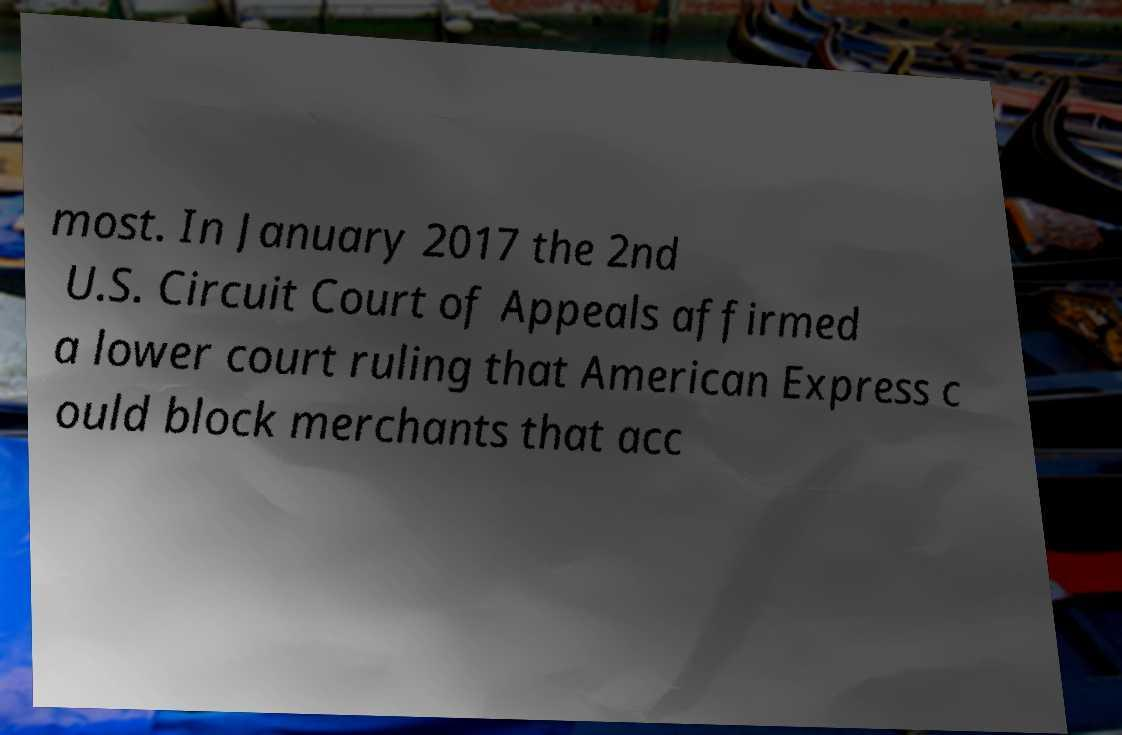Please identify and transcribe the text found in this image. most. In January 2017 the 2nd U.S. Circuit Court of Appeals affirmed a lower court ruling that American Express c ould block merchants that acc 